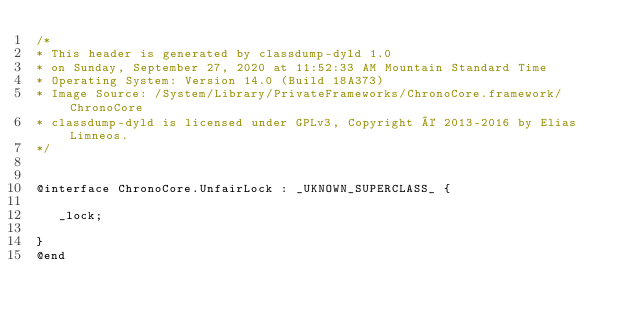<code> <loc_0><loc_0><loc_500><loc_500><_C_>/*
* This header is generated by classdump-dyld 1.0
* on Sunday, September 27, 2020 at 11:52:33 AM Mountain Standard Time
* Operating System: Version 14.0 (Build 18A373)
* Image Source: /System/Library/PrivateFrameworks/ChronoCore.framework/ChronoCore
* classdump-dyld is licensed under GPLv3, Copyright © 2013-2016 by Elias Limneos.
*/


@interface ChronoCore.UnfairLock : _UKNOWN_SUPERCLASS_ {

	 _lock;

}
@end

</code> 